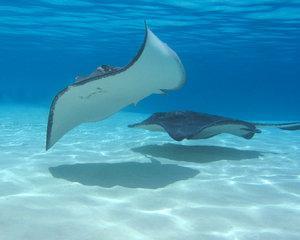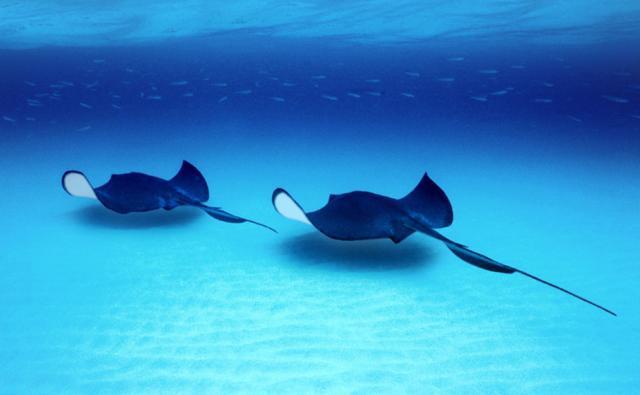The first image is the image on the left, the second image is the image on the right. Considering the images on both sides, is "Two or more people are in very clear ocean water with manta rays swimming around them." valid? Answer yes or no. No. The first image is the image on the left, the second image is the image on the right. Analyze the images presented: Is the assertion "There is at least one person in the water with at least one manta ray." valid? Answer yes or no. No. 